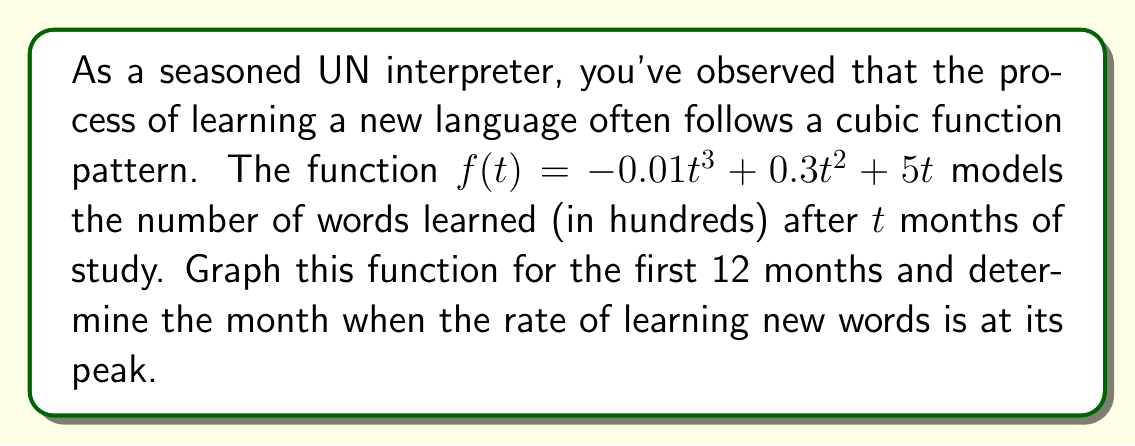Could you help me with this problem? To solve this problem, we'll follow these steps:

1) First, let's graph the function $f(t) = -0.01t^3 + 0.3t^2 + 5t$ for $t$ from 0 to 12.

[asy]
import graph;
size(200,200);
real f(real t) {return -0.01t^3 + 0.3t^2 + 5t;}
draw(graph(f,0,12),blue);
xaxis("t (months)",0,12,Arrow);
yaxis("f(t) (hundreds of words)",0,60,Arrow);
label("f(t) = -0.01t³ + 0.3t² + 5t",(6,55),E);
[/asy]

2) To find when the rate of learning is at its peak, we need to find the maximum of the derivative of $f(t)$.

3) The derivative of $f(t)$ is:
   $$f'(t) = -0.03t^2 + 0.6t + 5$$

4) To find the maximum of $f'(t)$, we need to find where its derivative equals zero:
   $$f''(t) = -0.06t + 0.6 = 0$$

5) Solving this equation:
   $$-0.06t + 0.6 = 0$$
   $$-0.06t = -0.6$$
   $$t = 10$$

6) We can confirm this is a maximum by checking the sign of $f''(t)$ before and after $t=10$:
   For $t < 10$, $f''(t) > 0$
   For $t > 10$, $f''(t) < 0$

Therefore, the rate of learning new words is at its peak at $t = 10$ months.
Answer: The rate of learning new words is at its peak after 10 months of study. 